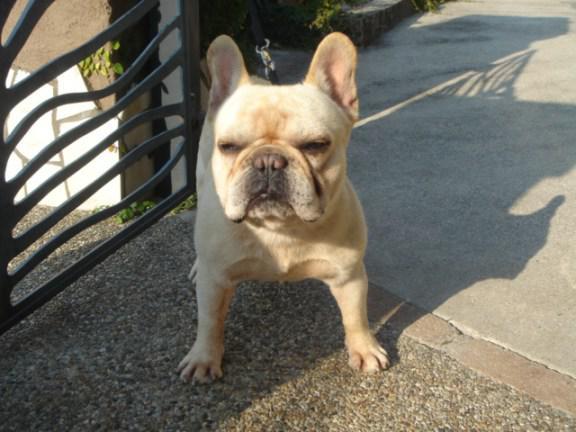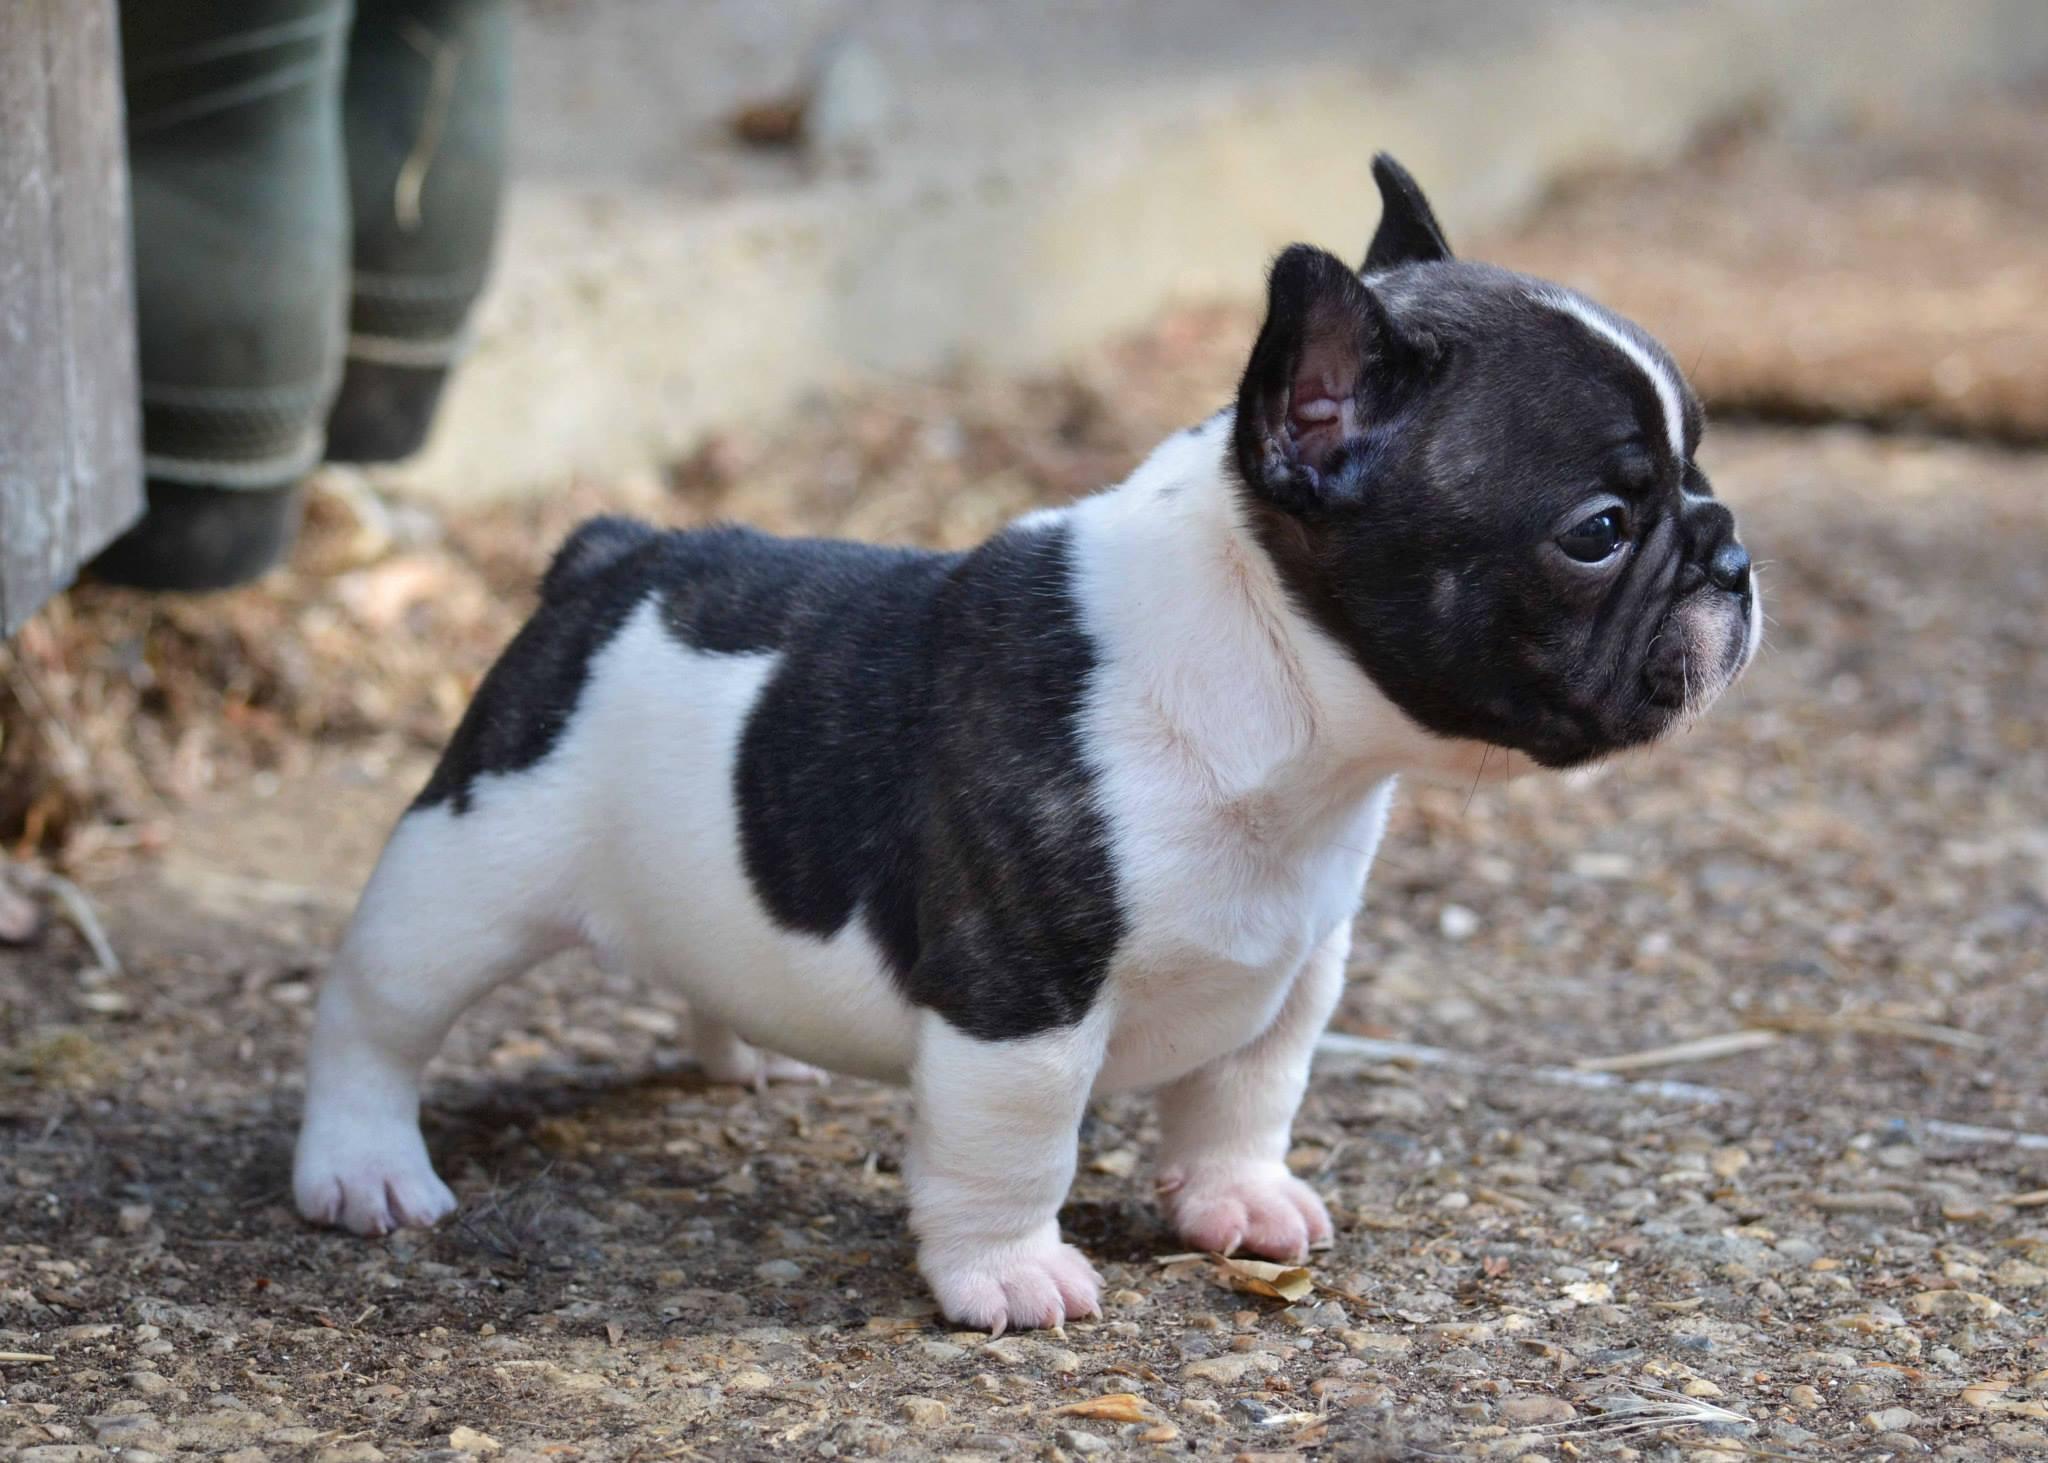The first image is the image on the left, the second image is the image on the right. Given the left and right images, does the statement "One tan dog and one black and white dog are shown." hold true? Answer yes or no. Yes. 